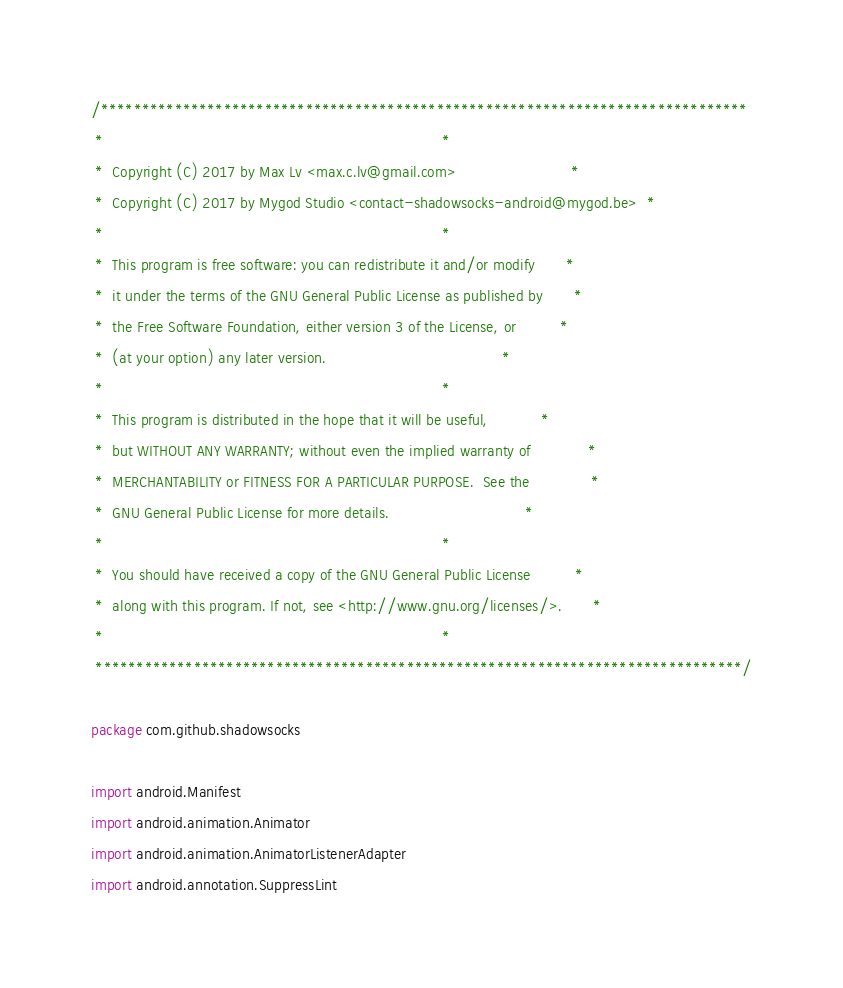<code> <loc_0><loc_0><loc_500><loc_500><_Kotlin_>/*******************************************************************************
 *                                                                             *
 *  Copyright (C) 2017 by Max Lv <max.c.lv@gmail.com>                          *
 *  Copyright (C) 2017 by Mygod Studio <contact-shadowsocks-android@mygod.be>  *
 *                                                                             *
 *  This program is free software: you can redistribute it and/or modify       *
 *  it under the terms of the GNU General Public License as published by       *
 *  the Free Software Foundation, either version 3 of the License, or          *
 *  (at your option) any later version.                                        *
 *                                                                             *
 *  This program is distributed in the hope that it will be useful,            *
 *  but WITHOUT ANY WARRANTY; without even the implied warranty of             *
 *  MERCHANTABILITY or FITNESS FOR A PARTICULAR PURPOSE.  See the              *
 *  GNU General Public License for more details.                               *
 *                                                                             *
 *  You should have received a copy of the GNU General Public License          *
 *  along with this program. If not, see <http://www.gnu.org/licenses/>.       *
 *                                                                             *
 *******************************************************************************/

package com.github.shadowsocks

import android.Manifest
import android.animation.Animator
import android.animation.AnimatorListenerAdapter
import android.annotation.SuppressLint</code> 